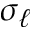<formula> <loc_0><loc_0><loc_500><loc_500>\sigma _ { \ell }</formula> 